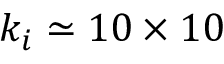<formula> <loc_0><loc_0><loc_500><loc_500>k _ { i } \simeq 1 0 \times 1 0</formula> 